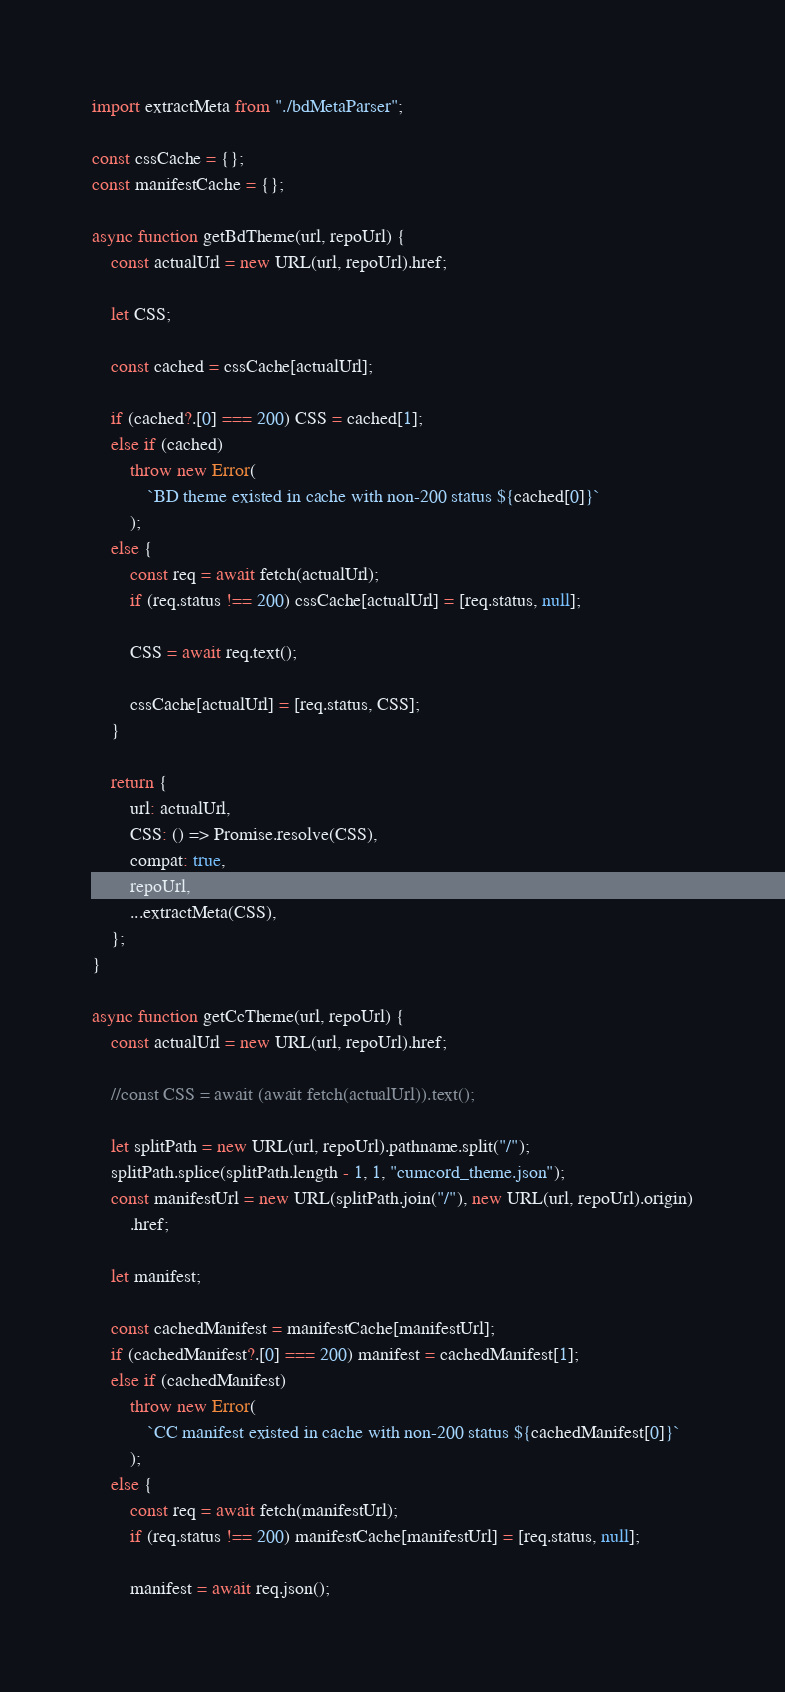Convert code to text. <code><loc_0><loc_0><loc_500><loc_500><_JavaScript_>import extractMeta from "./bdMetaParser";

const cssCache = {};
const manifestCache = {};

async function getBdTheme(url, repoUrl) {
	const actualUrl = new URL(url, repoUrl).href;

	let CSS;

	const cached = cssCache[actualUrl];

	if (cached?.[0] === 200) CSS = cached[1];
	else if (cached)
		throw new Error(
			`BD theme existed in cache with non-200 status ${cached[0]}`
		);
	else {
		const req = await fetch(actualUrl);
		if (req.status !== 200) cssCache[actualUrl] = [req.status, null];

		CSS = await req.text();

		cssCache[actualUrl] = [req.status, CSS];
	}

	return {
		url: actualUrl,
		CSS: () => Promise.resolve(CSS),
		compat: true,
		repoUrl,
		...extractMeta(CSS),
	};
}

async function getCcTheme(url, repoUrl) {
	const actualUrl = new URL(url, repoUrl).href;

	//const CSS = await (await fetch(actualUrl)).text();

	let splitPath = new URL(url, repoUrl).pathname.split("/");
	splitPath.splice(splitPath.length - 1, 1, "cumcord_theme.json");
	const manifestUrl = new URL(splitPath.join("/"), new URL(url, repoUrl).origin)
		.href;

	let manifest;

	const cachedManifest = manifestCache[manifestUrl];
	if (cachedManifest?.[0] === 200) manifest = cachedManifest[1];
	else if (cachedManifest)
		throw new Error(
			`CC manifest existed in cache with non-200 status ${cachedManifest[0]}`
		);
	else {
		const req = await fetch(manifestUrl);
		if (req.status !== 200) manifestCache[manifestUrl] = [req.status, null];

		manifest = await req.json();
</code> 